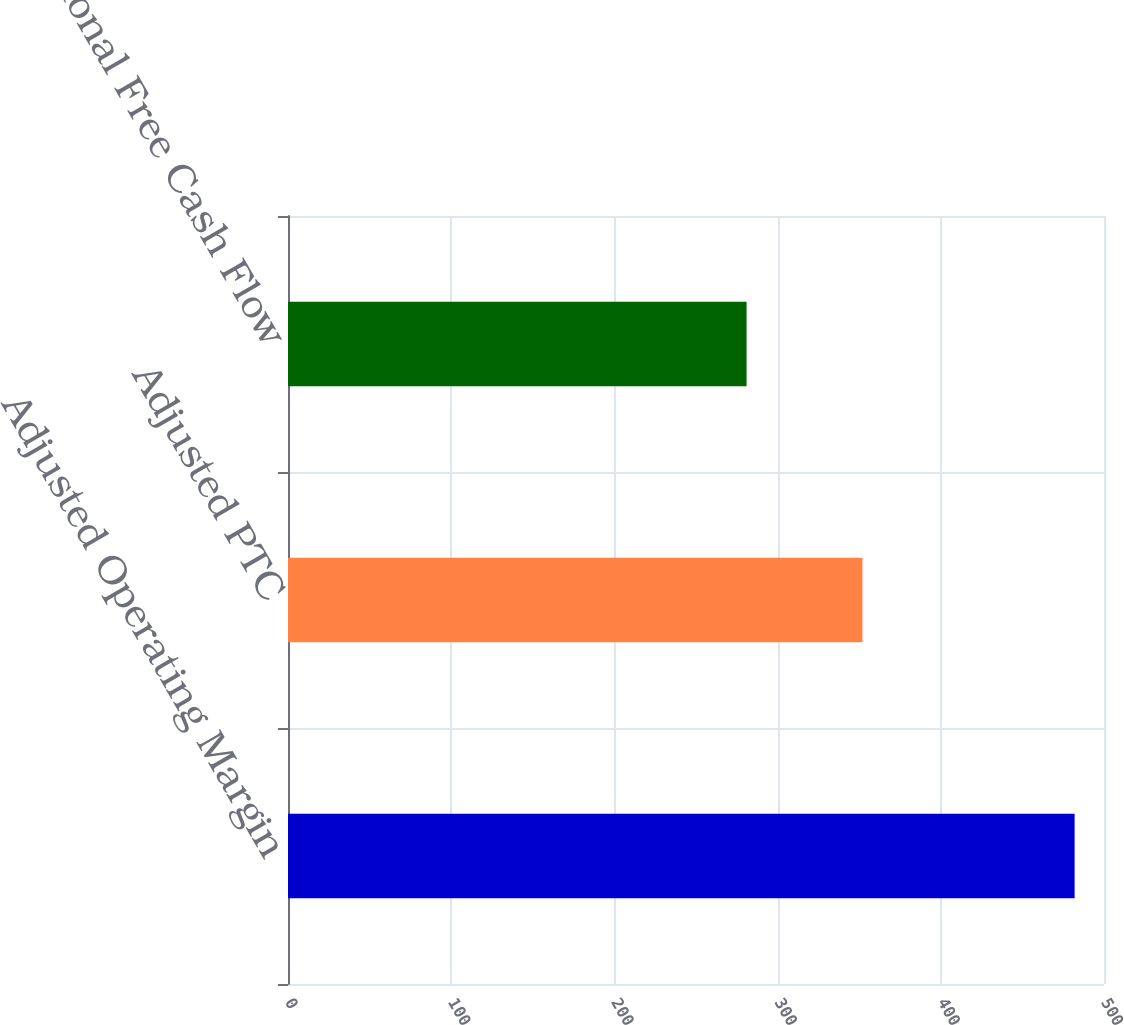<chart> <loc_0><loc_0><loc_500><loc_500><bar_chart><fcel>Adjusted Operating Margin<fcel>Adjusted PTC<fcel>Proportional Free Cash Flow<nl><fcel>482<fcel>352<fcel>281<nl></chart> 